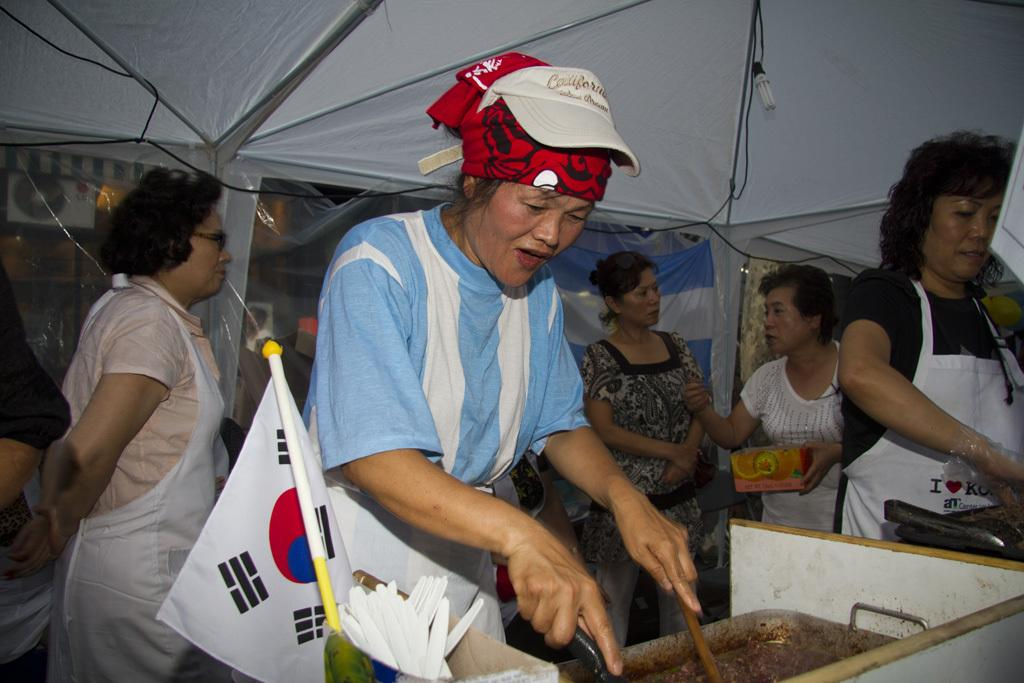What type of shelter is visible in the image? There is a tent in the image. What can be seen providing illumination in the image? There is a light in the image. What type of symbol or emblem is present in the image? There is a flag in the image. What type of dish or container is visible in the image? There is a dish in the image. How many people are present in the image? There are people in the image. What type of alley is visible in the image? There is no alley present in the image. Who is the representative of the people in the image? The image does not depict any specific representative of the people. What is the limit of the dish in the image? The image does not provide information about any limit associated with the dish. 